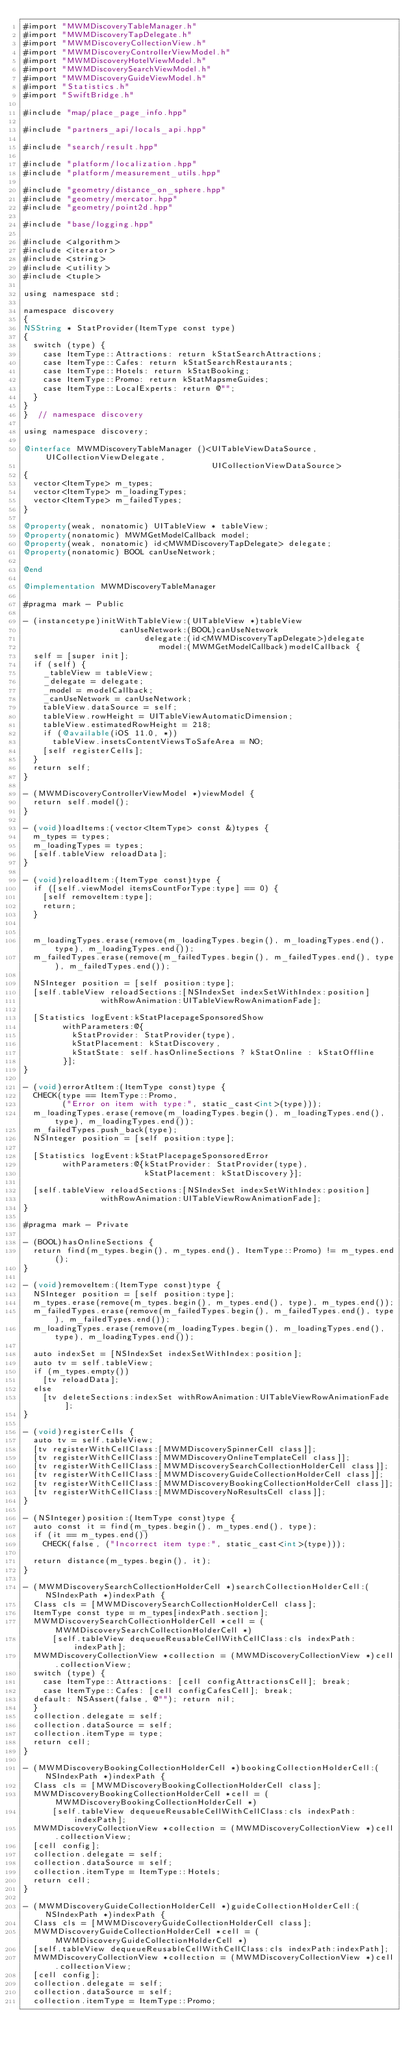<code> <loc_0><loc_0><loc_500><loc_500><_ObjectiveC_>#import "MWMDiscoveryTableManager.h"
#import "MWMDiscoveryTapDelegate.h"
#import "MWMDiscoveryCollectionView.h"
#import "MWMDiscoveryControllerViewModel.h"
#import "MWMDiscoveryHotelViewModel.h"
#import "MWMDiscoverySearchViewModel.h"
#import "MWMDiscoveryGuideViewModel.h"
#import "Statistics.h"
#import "SwiftBridge.h"

#include "map/place_page_info.hpp"

#include "partners_api/locals_api.hpp"

#include "search/result.hpp"

#include "platform/localization.hpp"
#include "platform/measurement_utils.hpp"

#include "geometry/distance_on_sphere.hpp"
#include "geometry/mercator.hpp"
#include "geometry/point2d.hpp"

#include "base/logging.hpp"

#include <algorithm>
#include <iterator>
#include <string>
#include <utility>
#include <tuple>

using namespace std;

namespace discovery
{
NSString * StatProvider(ItemType const type)
{
  switch (type) {
    case ItemType::Attractions: return kStatSearchAttractions;
    case ItemType::Cafes: return kStatSearchRestaurants;
    case ItemType::Hotels: return kStatBooking;
    case ItemType::Promo: return kStatMapsmeGuides;
    case ItemType::LocalExperts: return @"";
  }
}
}  // namespace discovery

using namespace discovery;

@interface MWMDiscoveryTableManager ()<UITableViewDataSource, UICollectionViewDelegate,
                                       UICollectionViewDataSource>
{
  vector<ItemType> m_types;
  vector<ItemType> m_loadingTypes;
  vector<ItemType> m_failedTypes;
}

@property(weak, nonatomic) UITableView * tableView;
@property(nonatomic) MWMGetModelCallback model;
@property(weak, nonatomic) id<MWMDiscoveryTapDelegate> delegate;
@property(nonatomic) BOOL canUseNetwork;

@end

@implementation MWMDiscoveryTableManager

#pragma mark - Public

- (instancetype)initWithTableView:(UITableView *)tableView
                    canUseNetwork:(BOOL)canUseNetwork
                         delegate:(id<MWMDiscoveryTapDelegate>)delegate
                            model:(MWMGetModelCallback)modelCallback {
  self = [super init];
  if (self) {
    _tableView = tableView;
    _delegate = delegate;
    _model = modelCallback;
    _canUseNetwork = canUseNetwork;
    tableView.dataSource = self;
    tableView.rowHeight = UITableViewAutomaticDimension;
    tableView.estimatedRowHeight = 218;
    if (@available(iOS 11.0, *))
      tableView.insetsContentViewsToSafeArea = NO;
    [self registerCells];
  }
  return self;
}

- (MWMDiscoveryControllerViewModel *)viewModel {
  return self.model();
}

- (void)loadItems:(vector<ItemType> const &)types {
  m_types = types;
  m_loadingTypes = types;
  [self.tableView reloadData];
}

- (void)reloadItem:(ItemType const)type {
  if ([self.viewModel itemsCountForType:type] == 0) {
    [self removeItem:type];
    return;
  }
  

  m_loadingTypes.erase(remove(m_loadingTypes.begin(), m_loadingTypes.end(), type), m_loadingTypes.end());
  m_failedTypes.erase(remove(m_failedTypes.begin(), m_failedTypes.end(), type), m_failedTypes.end());
  
  NSInteger position = [self position:type];
  [self.tableView reloadSections:[NSIndexSet indexSetWithIndex:position]
                withRowAnimation:UITableViewRowAnimationFade];

  [Statistics logEvent:kStatPlacepageSponsoredShow
        withParameters:@{
          kStatProvider: StatProvider(type),
          kStatPlacement: kStatDiscovery,
          kStatState: self.hasOnlineSections ? kStatOnline : kStatOffline
        }];
}

- (void)errorAtItem:(ItemType const)type {
  CHECK(type == ItemType::Promo,
        ("Error on item with type:", static_cast<int>(type)));
  m_loadingTypes.erase(remove(m_loadingTypes.begin(), m_loadingTypes.end(), type), m_loadingTypes.end());
  m_failedTypes.push_back(type);
  NSInteger position = [self position:type];

  [Statistics logEvent:kStatPlacepageSponsoredError
        withParameters:@{kStatProvider: StatProvider(type),
                         kStatPlacement: kStatDiscovery}];

  [self.tableView reloadSections:[NSIndexSet indexSetWithIndex:position]
                withRowAnimation:UITableViewRowAnimationFade];
}

#pragma mark - Private

- (BOOL)hasOnlineSections {
  return find(m_types.begin(), m_types.end(), ItemType::Promo) != m_types.end();
}

- (void)removeItem:(ItemType const)type {
  NSInteger position = [self position:type];
  m_types.erase(remove(m_types.begin(), m_types.end(), type), m_types.end());
  m_failedTypes.erase(remove(m_failedTypes.begin(), m_failedTypes.end(), type), m_failedTypes.end());
  m_loadingTypes.erase(remove(m_loadingTypes.begin(), m_loadingTypes.end(), type), m_loadingTypes.end());

  auto indexSet = [NSIndexSet indexSetWithIndex:position];
  auto tv = self.tableView;
  if (m_types.empty())
    [tv reloadData];
  else
    [tv deleteSections:indexSet withRowAnimation:UITableViewRowAnimationFade];
}

- (void)registerCells {
  auto tv = self.tableView;
  [tv registerWithCellClass:[MWMDiscoverySpinnerCell class]];
  [tv registerWithCellClass:[MWMDiscoveryOnlineTemplateCell class]];
  [tv registerWithCellClass:[MWMDiscoverySearchCollectionHolderCell class]];
  [tv registerWithCellClass:[MWMDiscoveryGuideCollectionHolderCell class]];
  [tv registerWithCellClass:[MWMDiscoveryBookingCollectionHolderCell class]];
  [tv registerWithCellClass:[MWMDiscoveryNoResultsCell class]];
}

- (NSInteger)position:(ItemType const)type {
  auto const it = find(m_types.begin(), m_types.end(), type);
  if (it == m_types.end())
    CHECK(false, ("Incorrect item type:", static_cast<int>(type)));
  
  return distance(m_types.begin(), it);
}

- (MWMDiscoverySearchCollectionHolderCell *)searchCollectionHolderCell:(NSIndexPath *)indexPath {
  Class cls = [MWMDiscoverySearchCollectionHolderCell class];
  ItemType const type = m_types[indexPath.section];
  MWMDiscoverySearchCollectionHolderCell *cell = (MWMDiscoverySearchCollectionHolderCell *)
      [self.tableView dequeueReusableCellWithCellClass:cls indexPath:indexPath];
  MWMDiscoveryCollectionView *collection = (MWMDiscoveryCollectionView *)cell.collectionView;
  switch (type) {
    case ItemType::Attractions: [cell configAttractionsCell]; break;
    case ItemType::Cafes: [cell configCafesCell]; break;
  default: NSAssert(false, @""); return nil;
  }
  collection.delegate = self;
  collection.dataSource = self;
  collection.itemType = type;
  return cell;
}

- (MWMDiscoveryBookingCollectionHolderCell *)bookingCollectionHolderCell:(NSIndexPath *)indexPath {
  Class cls = [MWMDiscoveryBookingCollectionHolderCell class];
  MWMDiscoveryBookingCollectionHolderCell *cell = (MWMDiscoveryBookingCollectionHolderCell *)
      [self.tableView dequeueReusableCellWithCellClass:cls indexPath:indexPath];
  MWMDiscoveryCollectionView *collection = (MWMDiscoveryCollectionView *)cell.collectionView;
  [cell config];
  collection.delegate = self;
  collection.dataSource = self;
  collection.itemType = ItemType::Hotels;
  return cell;
}

- (MWMDiscoveryGuideCollectionHolderCell *)guideCollectionHolderCell:(NSIndexPath *)indexPath {
  Class cls = [MWMDiscoveryGuideCollectionHolderCell class];
  MWMDiscoveryGuideCollectionHolderCell *cell = (MWMDiscoveryGuideCollectionHolderCell *)
  [self.tableView dequeueReusableCellWithCellClass:cls indexPath:indexPath];
  MWMDiscoveryCollectionView *collection = (MWMDiscoveryCollectionView *)cell.collectionView;
  [cell config];
  collection.delegate = self;
  collection.dataSource = self;
  collection.itemType = ItemType::Promo;</code> 